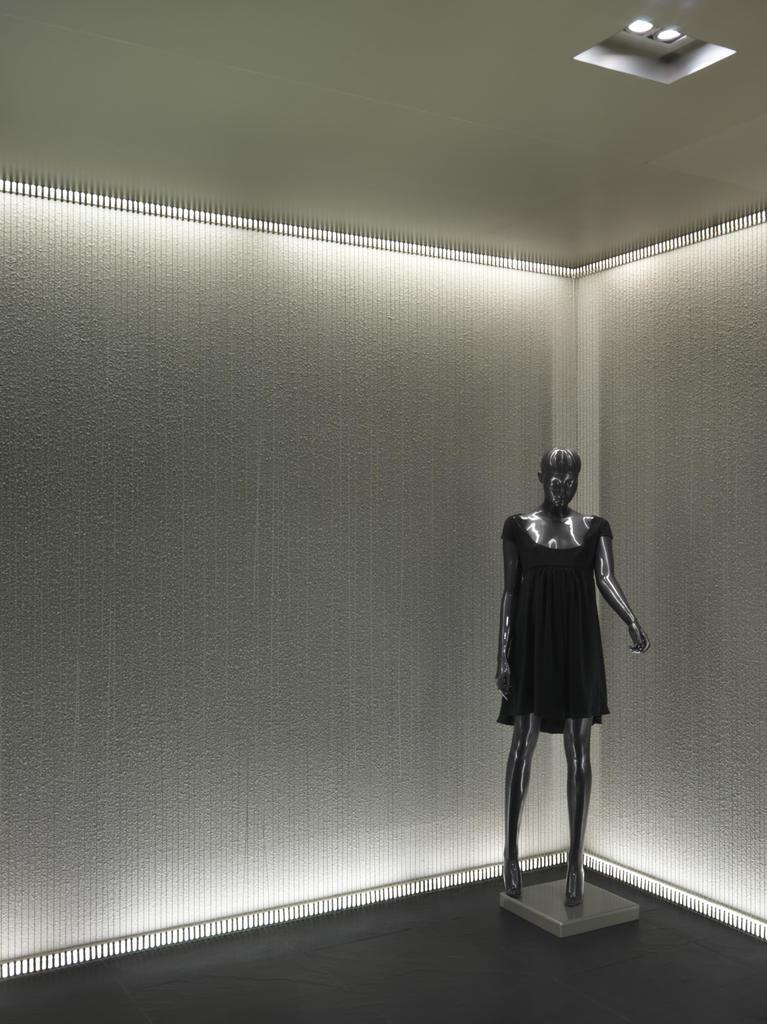What is the main subject in the image? There is a mannequin in the image. What can be seen in the background of the image? There is a wall in the background of the image. What is visible at the top of the image? There are lights visible at the top of the image. What type of quill is the mannequin holding in the image? There is no quill present in the image; the mannequin is not holding anything. Can you tell me how the dinosaurs are interacting with the mannequin in the image? There are no dinosaurs present in the image, so there is no interaction to describe. 